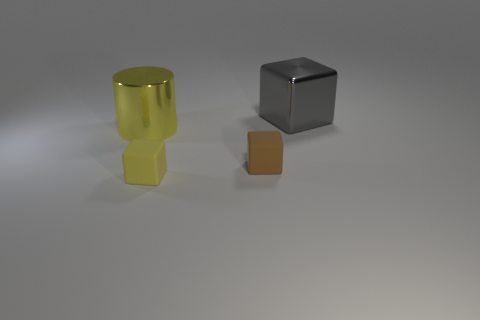Subtract all big gray cubes. How many cubes are left? 2 Subtract all yellow cubes. How many cubes are left? 2 Subtract 1 cylinders. How many cylinders are left? 0 Subtract all blocks. How many objects are left? 1 Subtract 1 brown blocks. How many objects are left? 3 Subtract all blue blocks. Subtract all brown cylinders. How many blocks are left? 3 Subtract all green cylinders. How many gray blocks are left? 1 Subtract all yellow shiny cylinders. Subtract all small matte things. How many objects are left? 1 Add 3 brown cubes. How many brown cubes are left? 4 Add 1 matte cubes. How many matte cubes exist? 3 